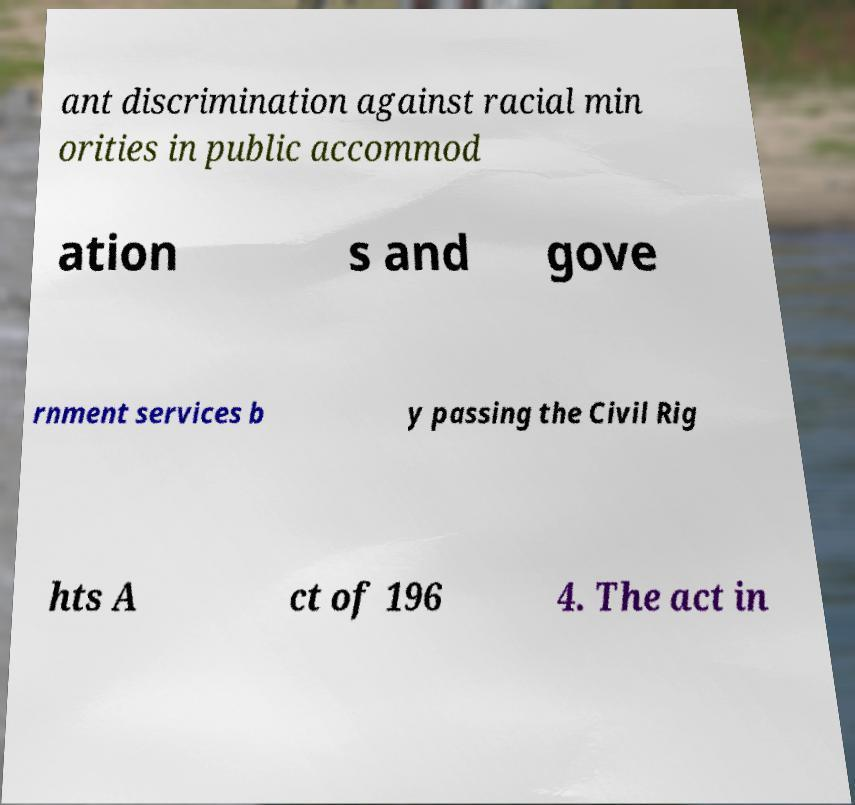Could you assist in decoding the text presented in this image and type it out clearly? ant discrimination against racial min orities in public accommod ation s and gove rnment services b y passing the Civil Rig hts A ct of 196 4. The act in 